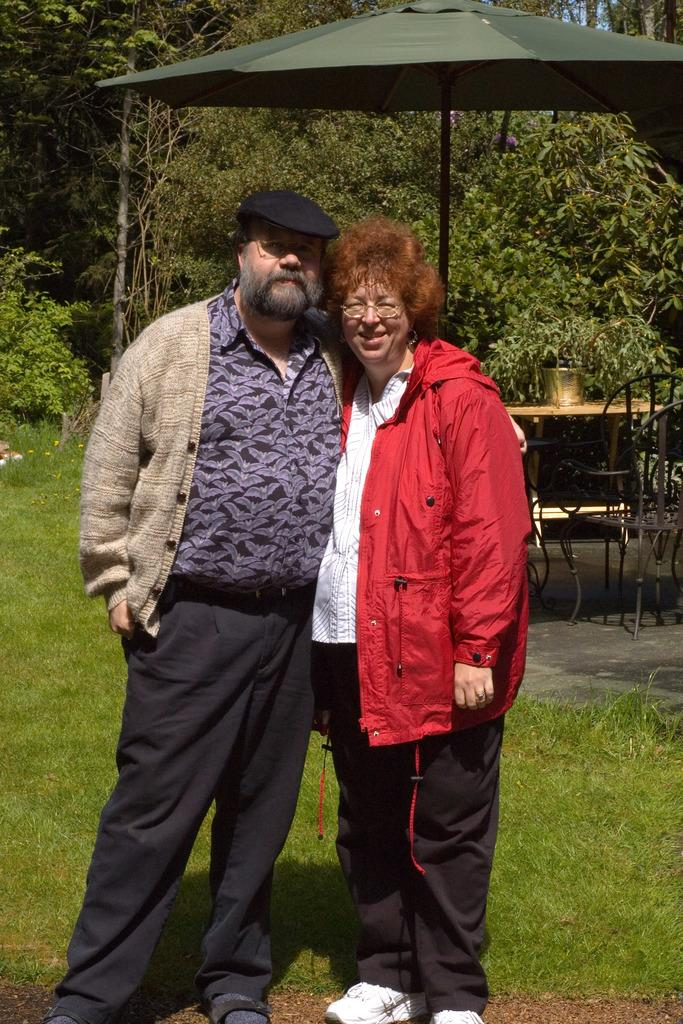How many people are present in the image? There is a man and a woman in the image, making a total of two people. What are the man and woman doing in the image? The man and woman are standing in the image. What type of furniture is visible in the image? There are chairs and a table in the image. What object is associated with the umbrella in the image? There is an umbrella with a pole in the image. What can be seen in the background of the image? There are trees in the background of the image. What type of juice is being served at the religious ceremony in the image? There is no religious ceremony or juice present in the image. The image only shows a man and a woman standing near chairs, a table, and an umbrella with a pole, with trees in the background. 